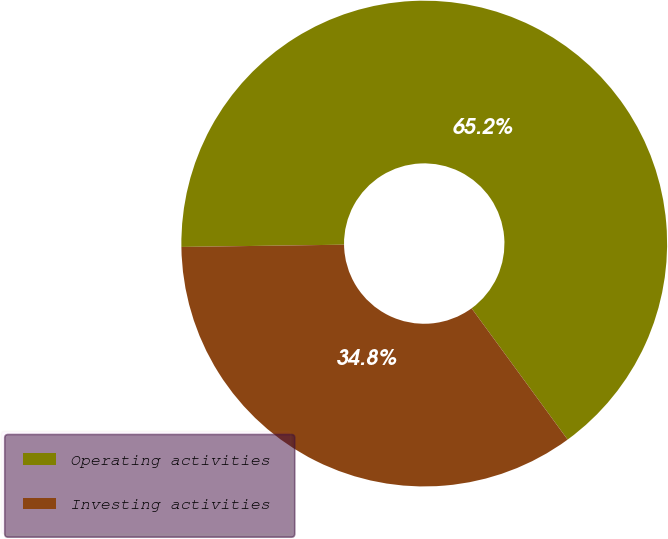Convert chart. <chart><loc_0><loc_0><loc_500><loc_500><pie_chart><fcel>Operating activities<fcel>Investing activities<nl><fcel>65.17%<fcel>34.83%<nl></chart> 